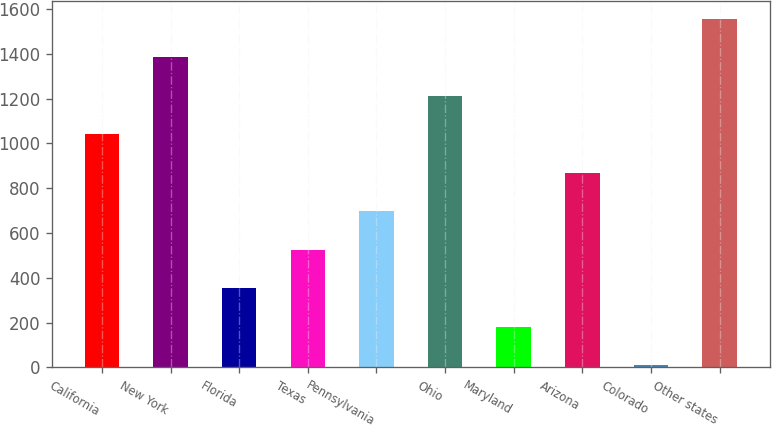Convert chart. <chart><loc_0><loc_0><loc_500><loc_500><bar_chart><fcel>California<fcel>New York<fcel>Florida<fcel>Texas<fcel>Pennsylvania<fcel>Ohio<fcel>Maryland<fcel>Arizona<fcel>Colorado<fcel>Other states<nl><fcel>1041.2<fcel>1384.6<fcel>354.4<fcel>526.1<fcel>697.8<fcel>1212.9<fcel>182.7<fcel>869.5<fcel>11<fcel>1556.3<nl></chart> 